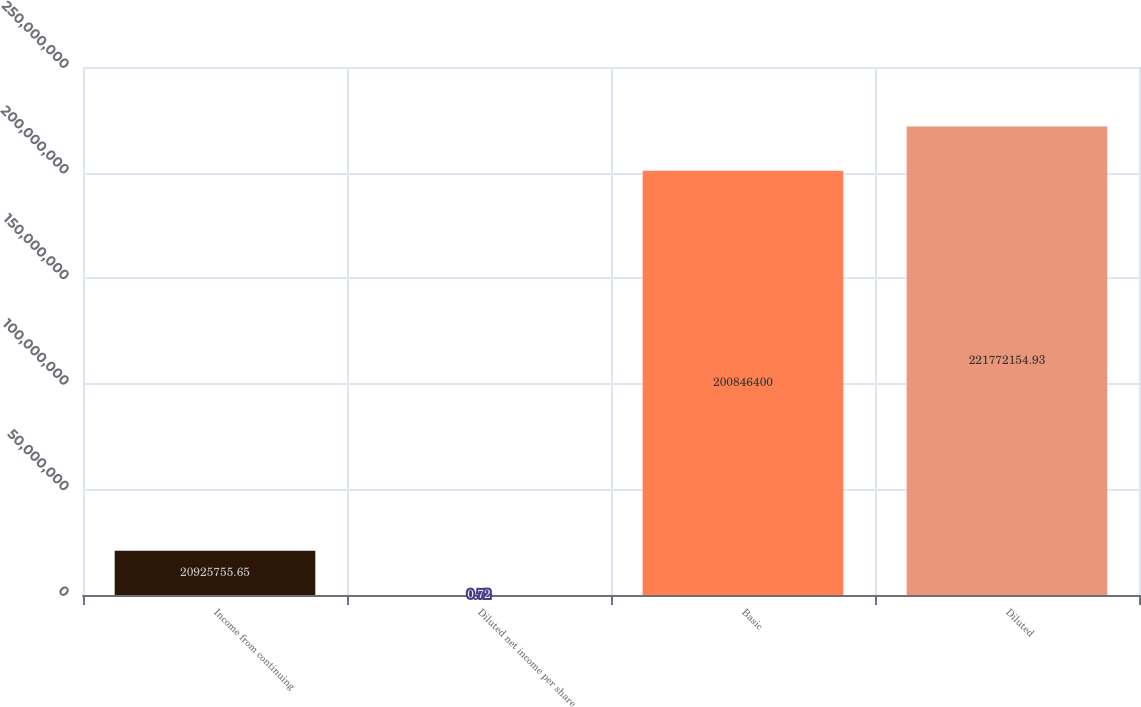Convert chart. <chart><loc_0><loc_0><loc_500><loc_500><bar_chart><fcel>Income from continuing<fcel>Diluted net income per share<fcel>Basic<fcel>Diluted<nl><fcel>2.09258e+07<fcel>0.72<fcel>2.00846e+08<fcel>2.21772e+08<nl></chart> 